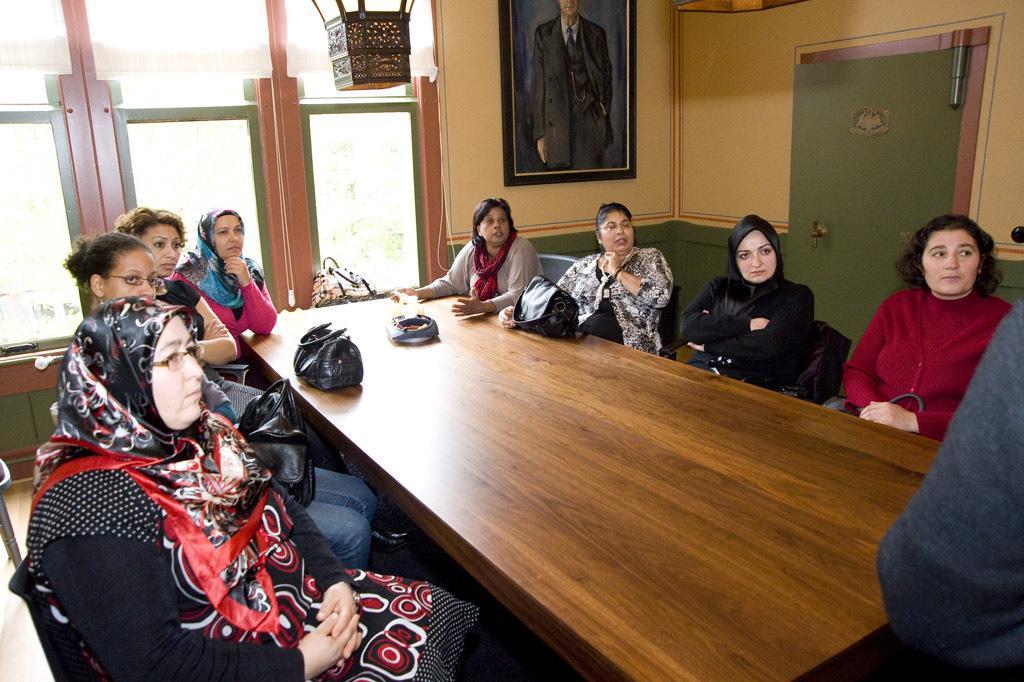How would you summarize this image in a sentence or two? In this image I see lot of women who are sitting on the chairs and there is a table in front of them, I can also see that there are few bags. In the background I see the window, a photo frame, wall and the door. 